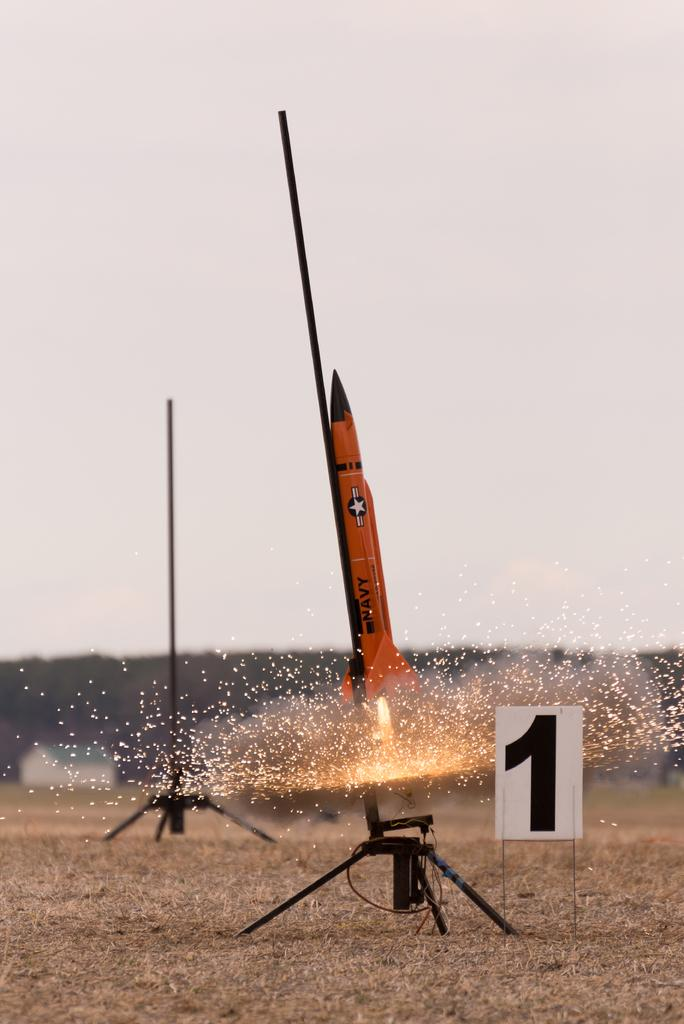What is flying in the sky in the image? There is a rocket flying in the sky in the image. How many stands can be seen in the image? There are two stands in the image. What is on the ground near the stands? There is a number tag on the ground. What can be seen in the background of the image? There is a house, trees, and the sky visible in the background of the image. How does the line increase in length in the image? There is no line present in the image that increases in length. 